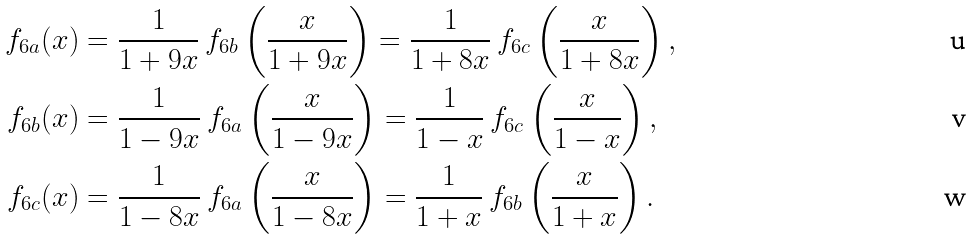<formula> <loc_0><loc_0><loc_500><loc_500>f _ { 6 a } ( x ) & = \frac { 1 } { 1 + 9 x } \, f _ { 6 b } \left ( \frac { x } { 1 + 9 x } \right ) = \frac { 1 } { 1 + 8 x } \, f _ { 6 c } \left ( \frac { x } { 1 + 8 x } \right ) , \\ f _ { 6 b } ( x ) & = \frac { 1 } { 1 - 9 x } \, f _ { 6 a } \left ( \frac { x } { 1 - 9 x } \right ) = \frac { 1 } { 1 - x } \, f _ { 6 c } \left ( \frac { x } { 1 - x } \right ) , \\ f _ { 6 c } ( x ) & = \frac { 1 } { 1 - 8 x } \, f _ { 6 a } \left ( \frac { x } { 1 - 8 x } \right ) = \frac { 1 } { 1 + x } \, f _ { 6 b } \left ( \frac { x } { 1 + x } \right ) .</formula> 